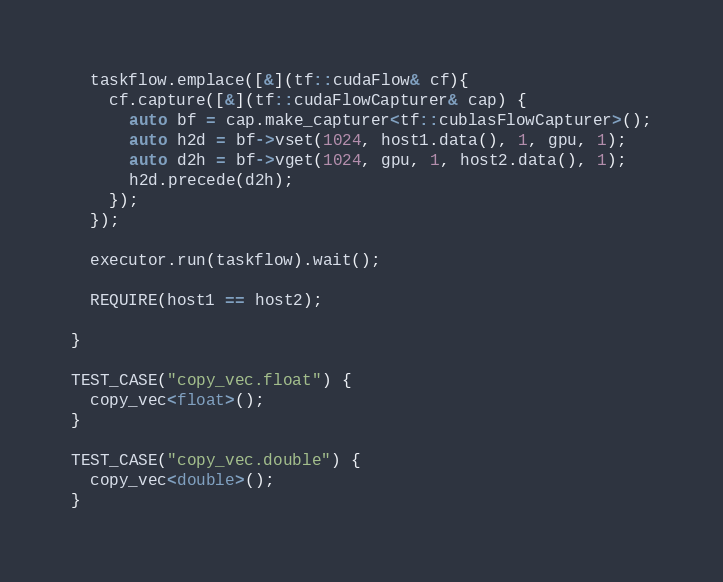<code> <loc_0><loc_0><loc_500><loc_500><_Cuda_>  taskflow.emplace([&](tf::cudaFlow& cf){
    cf.capture([&](tf::cudaFlowCapturer& cap) {
      auto bf = cap.make_capturer<tf::cublasFlowCapturer>();
      auto h2d = bf->vset(1024, host1.data(), 1, gpu, 1);
      auto d2h = bf->vget(1024, gpu, 1, host2.data(), 1);
      h2d.precede(d2h);
    });
  });

  executor.run(taskflow).wait();

  REQUIRE(host1 == host2);

}

TEST_CASE("copy_vec.float") {
  copy_vec<float>();
}

TEST_CASE("copy_vec.double") {
  copy_vec<double>();
}








</code> 